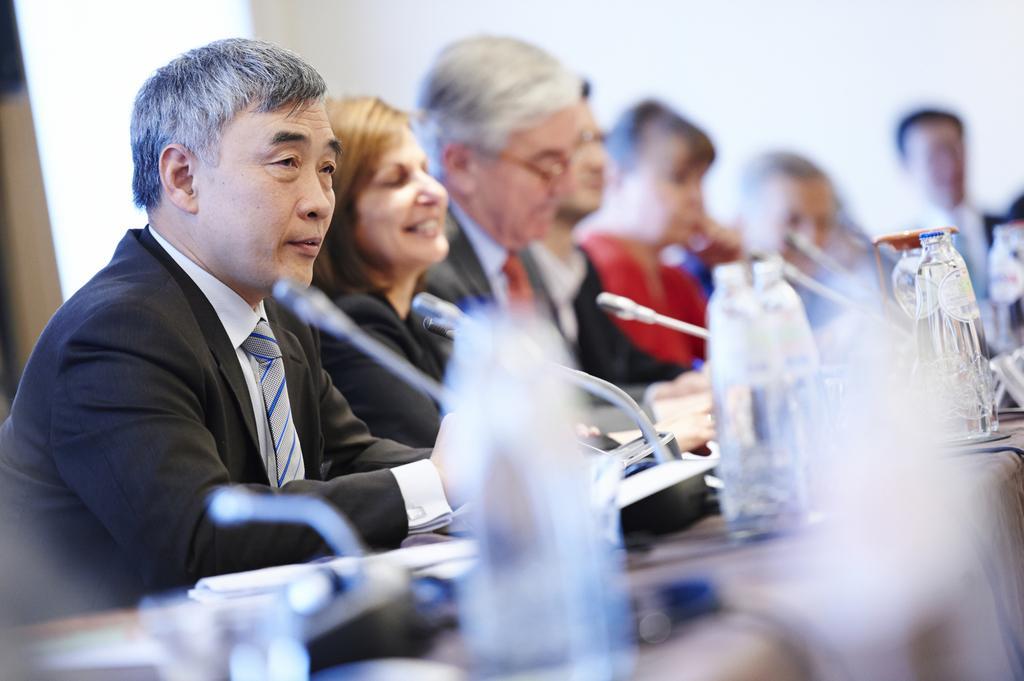How would you summarize this image in a sentence or two? In this image I can see few people are sitting. I can see all of them are wearing formal dress and here I can see few bottles and few mics. I can also see this image is little bit blurry. 